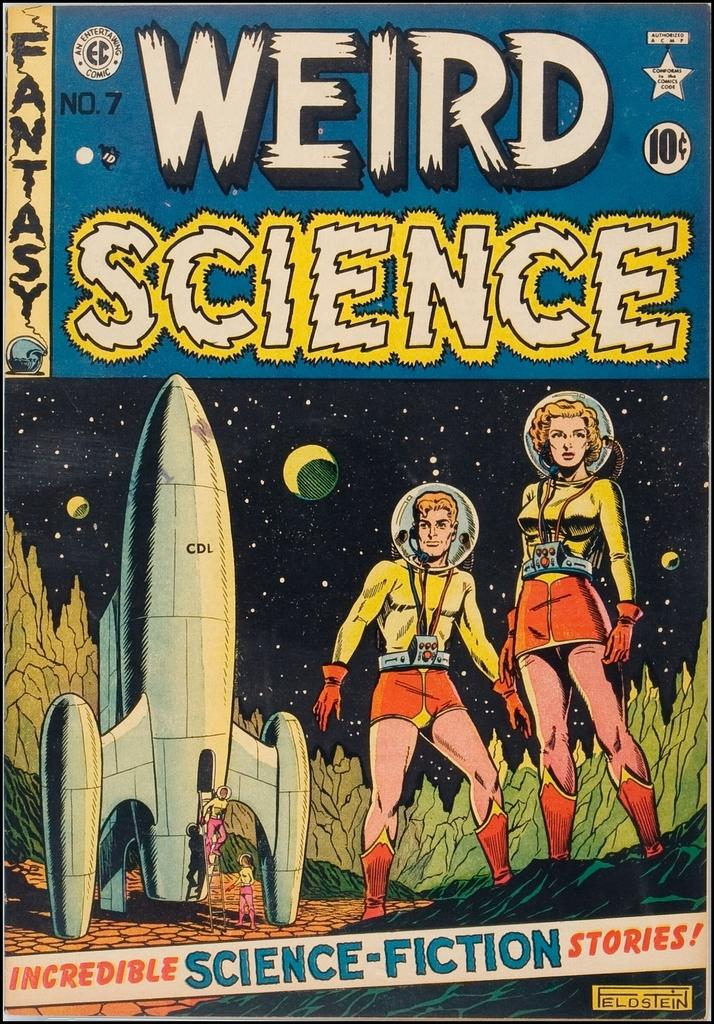<image>
Create a compact narrative representing the image presented. Volume number 7 of the Weird Science comic book series. 